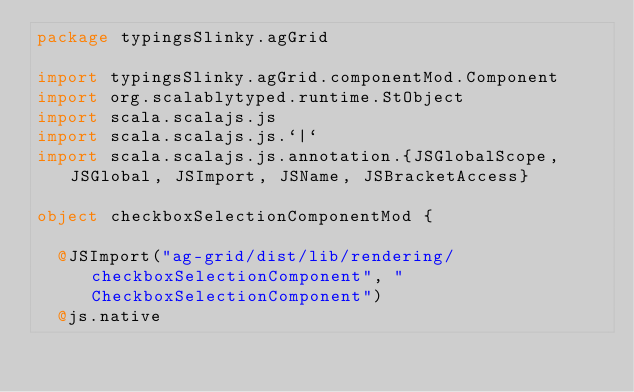Convert code to text. <code><loc_0><loc_0><loc_500><loc_500><_Scala_>package typingsSlinky.agGrid

import typingsSlinky.agGrid.componentMod.Component
import org.scalablytyped.runtime.StObject
import scala.scalajs.js
import scala.scalajs.js.`|`
import scala.scalajs.js.annotation.{JSGlobalScope, JSGlobal, JSImport, JSName, JSBracketAccess}

object checkboxSelectionComponentMod {
  
  @JSImport("ag-grid/dist/lib/rendering/checkboxSelectionComponent", "CheckboxSelectionComponent")
  @js.native</code> 